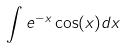<formula> <loc_0><loc_0><loc_500><loc_500>\int e ^ { - x } \cos ( x ) d x</formula> 